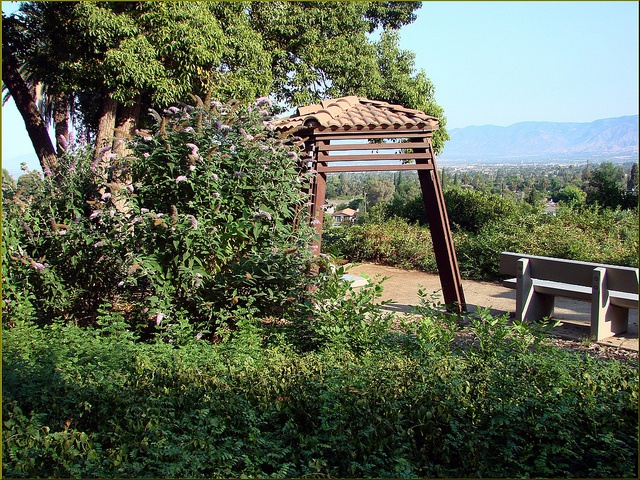Describe the objects in this image and their specific colors. I can see a bench in olive, black, lightgray, and gray tones in this image. 